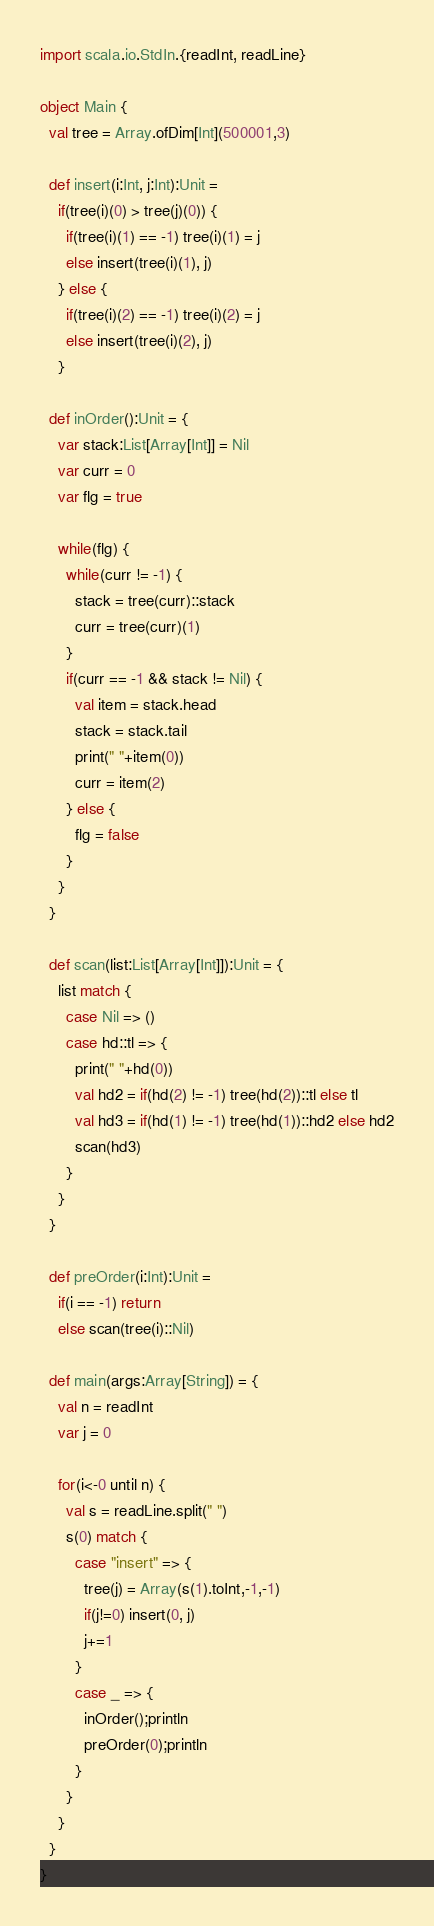Convert code to text. <code><loc_0><loc_0><loc_500><loc_500><_Scala_>import scala.io.StdIn.{readInt, readLine}

object Main {
  val tree = Array.ofDim[Int](500001,3)

  def insert(i:Int, j:Int):Unit =
    if(tree(i)(0) > tree(j)(0)) {
      if(tree(i)(1) == -1) tree(i)(1) = j
      else insert(tree(i)(1), j)
    } else {
      if(tree(i)(2) == -1) tree(i)(2) = j
      else insert(tree(i)(2), j)
    }

  def inOrder():Unit = {
    var stack:List[Array[Int]] = Nil
    var curr = 0
    var flg = true

    while(flg) {
      while(curr != -1) {
        stack = tree(curr)::stack
        curr = tree(curr)(1)
      }
      if(curr == -1 && stack != Nil) {
        val item = stack.head
        stack = stack.tail
        print(" "+item(0))
        curr = item(2)
      } else {
        flg = false
      }
    }
  }

  def scan(list:List[Array[Int]]):Unit = {
    list match {
      case Nil => ()
      case hd::tl => {
        print(" "+hd(0))
        val hd2 = if(hd(2) != -1) tree(hd(2))::tl else tl
        val hd3 = if(hd(1) != -1) tree(hd(1))::hd2 else hd2
        scan(hd3)
      }
    }
  }

  def preOrder(i:Int):Unit =
    if(i == -1) return
    else scan(tree(i)::Nil)

  def main(args:Array[String]) = {
    val n = readInt
    var j = 0

    for(i<-0 until n) {
      val s = readLine.split(" ")
      s(0) match {
        case "insert" => {
          tree(j) = Array(s(1).toInt,-1,-1)
          if(j!=0) insert(0, j)
          j+=1
        }
        case _ => {
          inOrder();println
          preOrder(0);println
        }
      }
    }
  }
}</code> 